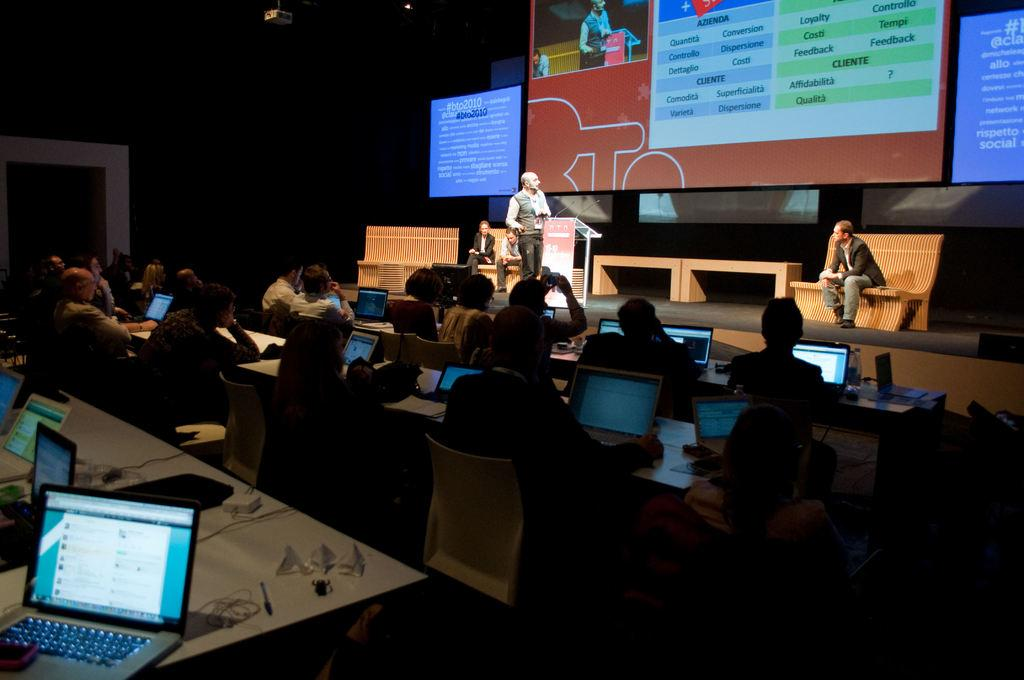<image>
Present a compact description of the photo's key features. Multiple computer screens are shown featuring the hashtag #bto2010. 